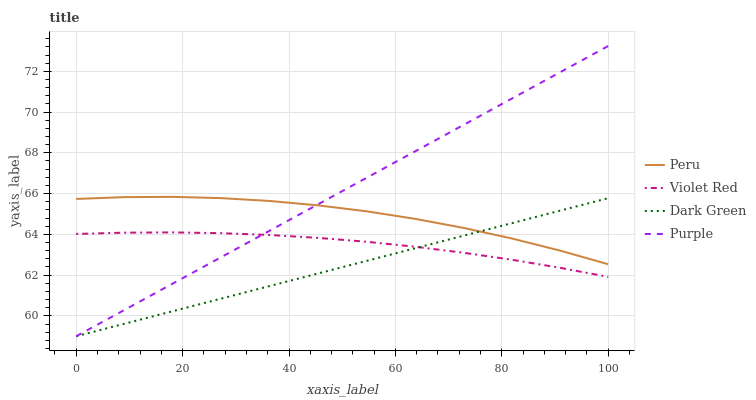Does Dark Green have the minimum area under the curve?
Answer yes or no. Yes. Does Purple have the maximum area under the curve?
Answer yes or no. Yes. Does Violet Red have the minimum area under the curve?
Answer yes or no. No. Does Violet Red have the maximum area under the curve?
Answer yes or no. No. Is Purple the smoothest?
Answer yes or no. Yes. Is Peru the roughest?
Answer yes or no. Yes. Is Violet Red the smoothest?
Answer yes or no. No. Is Violet Red the roughest?
Answer yes or no. No. Does Purple have the lowest value?
Answer yes or no. Yes. Does Violet Red have the lowest value?
Answer yes or no. No. Does Purple have the highest value?
Answer yes or no. Yes. Does Peru have the highest value?
Answer yes or no. No. Is Violet Red less than Peru?
Answer yes or no. Yes. Is Peru greater than Violet Red?
Answer yes or no. Yes. Does Dark Green intersect Peru?
Answer yes or no. Yes. Is Dark Green less than Peru?
Answer yes or no. No. Is Dark Green greater than Peru?
Answer yes or no. No. Does Violet Red intersect Peru?
Answer yes or no. No. 